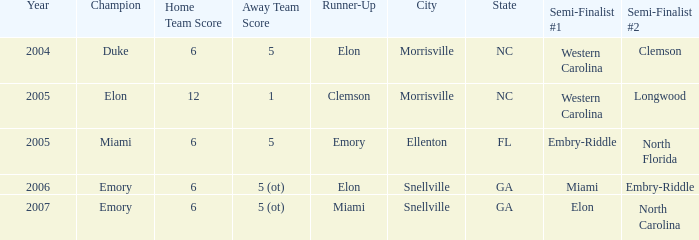Which team was the second semi finalist in 2007? North Carolina. 